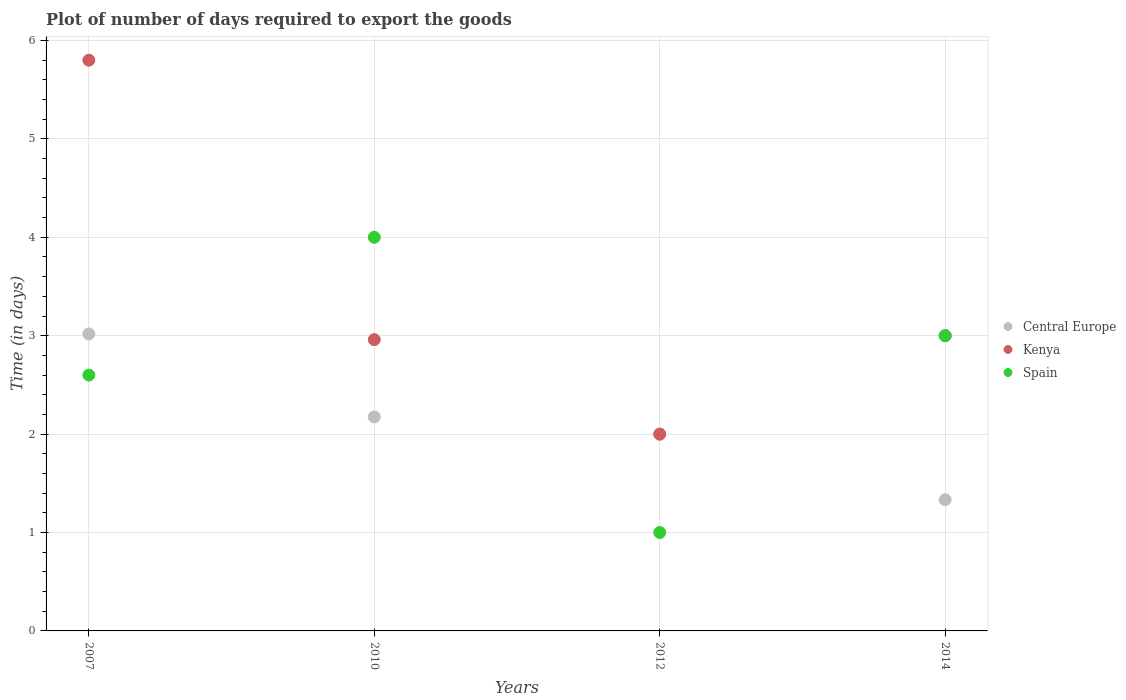Is the number of dotlines equal to the number of legend labels?
Give a very brief answer. Yes. In which year was the time required to export goods in Kenya minimum?
Give a very brief answer. 2012. What is the total time required to export goods in Kenya in the graph?
Offer a very short reply. 13.76. What is the difference between the time required to export goods in Central Europe in 2012 and that in 2014?
Offer a very short reply. 0.67. What is the difference between the time required to export goods in Central Europe in 2010 and the time required to export goods in Kenya in 2007?
Provide a short and direct response. -3.62. What is the average time required to export goods in Kenya per year?
Your answer should be very brief. 3.44. What is the ratio of the time required to export goods in Spain in 2007 to that in 2012?
Offer a very short reply. 2.6. Is the time required to export goods in Central Europe in 2007 less than that in 2012?
Provide a succinct answer. No. What is the difference between the highest and the second highest time required to export goods in Central Europe?
Give a very brief answer. 0.84. Is the sum of the time required to export goods in Kenya in 2012 and 2014 greater than the maximum time required to export goods in Spain across all years?
Your answer should be very brief. Yes. Is it the case that in every year, the sum of the time required to export goods in Kenya and time required to export goods in Spain  is greater than the time required to export goods in Central Europe?
Offer a terse response. Yes. Does the time required to export goods in Spain monotonically increase over the years?
Provide a short and direct response. No. Is the time required to export goods in Kenya strictly greater than the time required to export goods in Spain over the years?
Give a very brief answer. No. Is the time required to export goods in Kenya strictly less than the time required to export goods in Central Europe over the years?
Your answer should be very brief. No. What is the difference between two consecutive major ticks on the Y-axis?
Your answer should be compact. 1. Does the graph contain any zero values?
Provide a short and direct response. No. Does the graph contain grids?
Provide a succinct answer. Yes. Where does the legend appear in the graph?
Provide a succinct answer. Center right. How many legend labels are there?
Give a very brief answer. 3. How are the legend labels stacked?
Offer a terse response. Vertical. What is the title of the graph?
Ensure brevity in your answer.  Plot of number of days required to export the goods. Does "Djibouti" appear as one of the legend labels in the graph?
Make the answer very short. No. What is the label or title of the X-axis?
Ensure brevity in your answer.  Years. What is the label or title of the Y-axis?
Give a very brief answer. Time (in days). What is the Time (in days) in Central Europe in 2007?
Make the answer very short. 3.02. What is the Time (in days) of Kenya in 2007?
Make the answer very short. 5.8. What is the Time (in days) of Spain in 2007?
Ensure brevity in your answer.  2.6. What is the Time (in days) of Central Europe in 2010?
Keep it short and to the point. 2.17. What is the Time (in days) in Kenya in 2010?
Offer a terse response. 2.96. What is the Time (in days) in Kenya in 2012?
Provide a short and direct response. 2. What is the Time (in days) in Central Europe in 2014?
Provide a short and direct response. 1.33. What is the Time (in days) in Spain in 2014?
Your answer should be compact. 3. Across all years, what is the maximum Time (in days) in Central Europe?
Provide a succinct answer. 3.02. Across all years, what is the maximum Time (in days) of Spain?
Keep it short and to the point. 4. Across all years, what is the minimum Time (in days) of Central Europe?
Your response must be concise. 1.33. Across all years, what is the minimum Time (in days) in Kenya?
Make the answer very short. 2. Across all years, what is the minimum Time (in days) in Spain?
Offer a terse response. 1. What is the total Time (in days) in Central Europe in the graph?
Ensure brevity in your answer.  8.53. What is the total Time (in days) of Kenya in the graph?
Give a very brief answer. 13.76. What is the difference between the Time (in days) of Central Europe in 2007 and that in 2010?
Your answer should be compact. 0.84. What is the difference between the Time (in days) in Kenya in 2007 and that in 2010?
Ensure brevity in your answer.  2.84. What is the difference between the Time (in days) of Spain in 2007 and that in 2010?
Make the answer very short. -1.4. What is the difference between the Time (in days) of Central Europe in 2007 and that in 2012?
Offer a terse response. 1.02. What is the difference between the Time (in days) in Kenya in 2007 and that in 2012?
Your response must be concise. 3.8. What is the difference between the Time (in days) in Central Europe in 2007 and that in 2014?
Your answer should be compact. 1.68. What is the difference between the Time (in days) in Kenya in 2007 and that in 2014?
Keep it short and to the point. 2.8. What is the difference between the Time (in days) in Spain in 2007 and that in 2014?
Your answer should be compact. -0.4. What is the difference between the Time (in days) of Central Europe in 2010 and that in 2012?
Your answer should be compact. 0.17. What is the difference between the Time (in days) in Central Europe in 2010 and that in 2014?
Give a very brief answer. 0.84. What is the difference between the Time (in days) in Kenya in 2010 and that in 2014?
Your answer should be compact. -0.04. What is the difference between the Time (in days) in Central Europe in 2007 and the Time (in days) in Kenya in 2010?
Your response must be concise. 0.06. What is the difference between the Time (in days) of Central Europe in 2007 and the Time (in days) of Spain in 2010?
Ensure brevity in your answer.  -0.98. What is the difference between the Time (in days) of Kenya in 2007 and the Time (in days) of Spain in 2010?
Ensure brevity in your answer.  1.8. What is the difference between the Time (in days) of Central Europe in 2007 and the Time (in days) of Kenya in 2012?
Ensure brevity in your answer.  1.02. What is the difference between the Time (in days) of Central Europe in 2007 and the Time (in days) of Spain in 2012?
Provide a short and direct response. 2.02. What is the difference between the Time (in days) of Kenya in 2007 and the Time (in days) of Spain in 2012?
Your answer should be compact. 4.8. What is the difference between the Time (in days) in Central Europe in 2007 and the Time (in days) in Kenya in 2014?
Ensure brevity in your answer.  0.02. What is the difference between the Time (in days) in Central Europe in 2007 and the Time (in days) in Spain in 2014?
Keep it short and to the point. 0.02. What is the difference between the Time (in days) in Kenya in 2007 and the Time (in days) in Spain in 2014?
Offer a very short reply. 2.8. What is the difference between the Time (in days) of Central Europe in 2010 and the Time (in days) of Kenya in 2012?
Your answer should be very brief. 0.17. What is the difference between the Time (in days) of Central Europe in 2010 and the Time (in days) of Spain in 2012?
Your answer should be compact. 1.18. What is the difference between the Time (in days) in Kenya in 2010 and the Time (in days) in Spain in 2012?
Provide a succinct answer. 1.96. What is the difference between the Time (in days) of Central Europe in 2010 and the Time (in days) of Kenya in 2014?
Offer a very short reply. -0.82. What is the difference between the Time (in days) of Central Europe in 2010 and the Time (in days) of Spain in 2014?
Your response must be concise. -0.82. What is the difference between the Time (in days) in Kenya in 2010 and the Time (in days) in Spain in 2014?
Offer a very short reply. -0.04. What is the average Time (in days) in Central Europe per year?
Provide a short and direct response. 2.13. What is the average Time (in days) of Kenya per year?
Ensure brevity in your answer.  3.44. What is the average Time (in days) of Spain per year?
Provide a succinct answer. 2.65. In the year 2007, what is the difference between the Time (in days) of Central Europe and Time (in days) of Kenya?
Your answer should be very brief. -2.78. In the year 2007, what is the difference between the Time (in days) of Central Europe and Time (in days) of Spain?
Give a very brief answer. 0.42. In the year 2010, what is the difference between the Time (in days) of Central Europe and Time (in days) of Kenya?
Offer a very short reply. -0.79. In the year 2010, what is the difference between the Time (in days) in Central Europe and Time (in days) in Spain?
Your answer should be very brief. -1.82. In the year 2010, what is the difference between the Time (in days) in Kenya and Time (in days) in Spain?
Provide a succinct answer. -1.04. In the year 2012, what is the difference between the Time (in days) in Central Europe and Time (in days) in Kenya?
Offer a very short reply. 0. In the year 2012, what is the difference between the Time (in days) of Central Europe and Time (in days) of Spain?
Keep it short and to the point. 1. In the year 2012, what is the difference between the Time (in days) in Kenya and Time (in days) in Spain?
Provide a succinct answer. 1. In the year 2014, what is the difference between the Time (in days) of Central Europe and Time (in days) of Kenya?
Ensure brevity in your answer.  -1.67. In the year 2014, what is the difference between the Time (in days) of Central Europe and Time (in days) of Spain?
Make the answer very short. -1.67. What is the ratio of the Time (in days) in Central Europe in 2007 to that in 2010?
Provide a succinct answer. 1.39. What is the ratio of the Time (in days) of Kenya in 2007 to that in 2010?
Ensure brevity in your answer.  1.96. What is the ratio of the Time (in days) in Spain in 2007 to that in 2010?
Give a very brief answer. 0.65. What is the ratio of the Time (in days) of Central Europe in 2007 to that in 2012?
Your answer should be compact. 1.51. What is the ratio of the Time (in days) in Spain in 2007 to that in 2012?
Make the answer very short. 2.6. What is the ratio of the Time (in days) in Central Europe in 2007 to that in 2014?
Your answer should be compact. 2.26. What is the ratio of the Time (in days) in Kenya in 2007 to that in 2014?
Offer a terse response. 1.93. What is the ratio of the Time (in days) in Spain in 2007 to that in 2014?
Offer a terse response. 0.87. What is the ratio of the Time (in days) in Central Europe in 2010 to that in 2012?
Provide a succinct answer. 1.09. What is the ratio of the Time (in days) in Kenya in 2010 to that in 2012?
Make the answer very short. 1.48. What is the ratio of the Time (in days) in Central Europe in 2010 to that in 2014?
Provide a short and direct response. 1.63. What is the ratio of the Time (in days) of Kenya in 2010 to that in 2014?
Keep it short and to the point. 0.99. What is the ratio of the Time (in days) in Central Europe in 2012 to that in 2014?
Ensure brevity in your answer.  1.5. What is the ratio of the Time (in days) of Spain in 2012 to that in 2014?
Provide a short and direct response. 0.33. What is the difference between the highest and the second highest Time (in days) in Central Europe?
Ensure brevity in your answer.  0.84. What is the difference between the highest and the second highest Time (in days) of Kenya?
Your answer should be compact. 2.8. What is the difference between the highest and the lowest Time (in days) of Central Europe?
Offer a very short reply. 1.68. What is the difference between the highest and the lowest Time (in days) in Kenya?
Make the answer very short. 3.8. What is the difference between the highest and the lowest Time (in days) of Spain?
Provide a short and direct response. 3. 